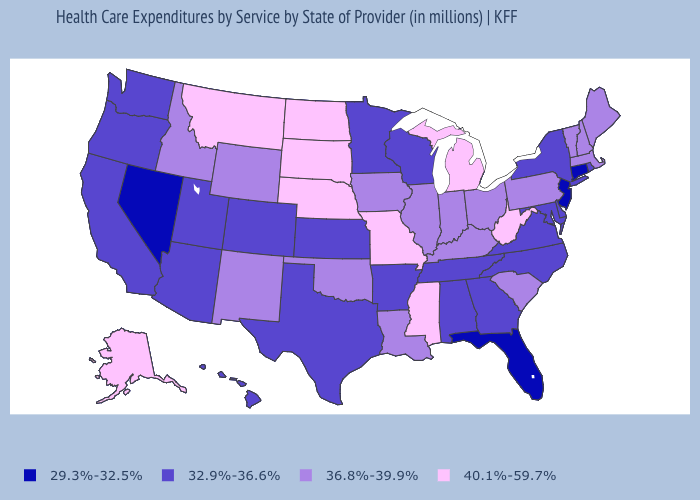What is the value of Oregon?
Be succinct. 32.9%-36.6%. Does Wyoming have a higher value than Delaware?
Short answer required. Yes. What is the value of New Hampshire?
Give a very brief answer. 36.8%-39.9%. How many symbols are there in the legend?
Give a very brief answer. 4. Among the states that border Mississippi , which have the lowest value?
Answer briefly. Alabama, Arkansas, Tennessee. Which states have the lowest value in the USA?
Quick response, please. Connecticut, Florida, Nevada, New Jersey. Does the first symbol in the legend represent the smallest category?
Keep it brief. Yes. Name the states that have a value in the range 40.1%-59.7%?
Be succinct. Alaska, Michigan, Mississippi, Missouri, Montana, Nebraska, North Dakota, South Dakota, West Virginia. Name the states that have a value in the range 32.9%-36.6%?
Answer briefly. Alabama, Arizona, Arkansas, California, Colorado, Delaware, Georgia, Hawaii, Kansas, Maryland, Minnesota, New York, North Carolina, Oregon, Rhode Island, Tennessee, Texas, Utah, Virginia, Washington, Wisconsin. What is the value of Oregon?
Be succinct. 32.9%-36.6%. Does Massachusetts have a higher value than Nevada?
Give a very brief answer. Yes. What is the value of Connecticut?
Keep it brief. 29.3%-32.5%. What is the highest value in the USA?
Keep it brief. 40.1%-59.7%. Among the states that border Alabama , does Florida have the lowest value?
Answer briefly. Yes. What is the value of Maryland?
Concise answer only. 32.9%-36.6%. 